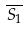<formula> <loc_0><loc_0><loc_500><loc_500>\overline { S _ { 1 } }</formula> 